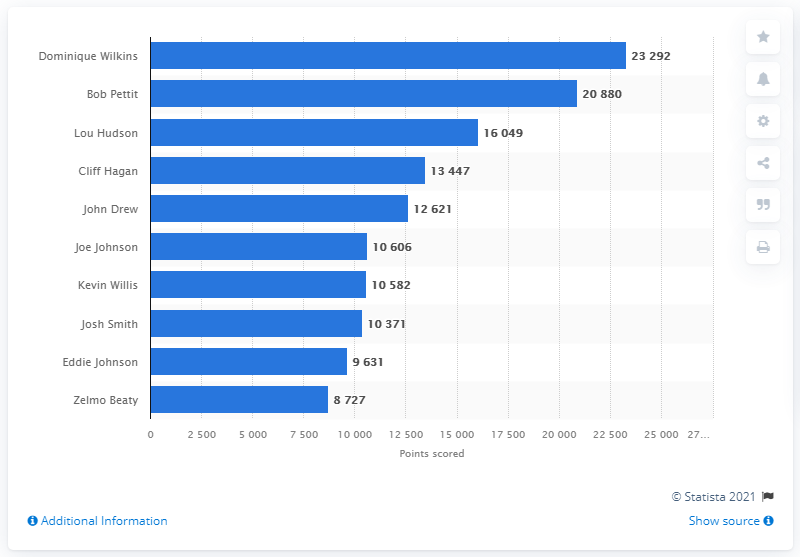Outline some significant characteristics in this image. Dominique Wilkins is the career points leader of the Atlanta Hawks. 